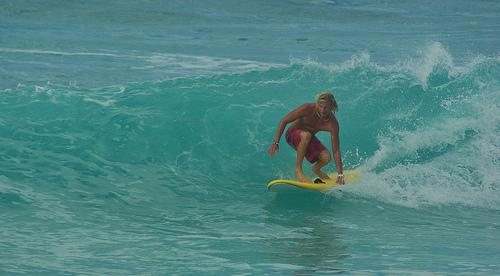Question: how many surfer?
Choices:
A. 1.
B. 2.
C. 3.
D. 4.
Answer with the letter. Answer: A Question: who is surfing?
Choices:
A. The woman.
B. The children.
C. The man.
D. The vacationers.
Answer with the letter. Answer: C Question: why is he surfing?
Choices:
A. A competition.
B. It's fun.
C. Practice.
D. Relaxation.
Answer with the letter. Answer: B Question: where is the board?
Choices:
A. On the beach.
B. In the water.
C. On top of the car.
D. Under the surfer.
Answer with the letter. Answer: D Question: what color is the board?
Choices:
A. Red.
B. Blue.
C. Yellow.
D. Green.
Answer with the letter. Answer: C Question: what is on the board?
Choices:
A. Nails.
B. Skater.
C. Dog.
D. The surfer.
Answer with the letter. Answer: D 